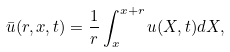<formula> <loc_0><loc_0><loc_500><loc_500>\bar { u } ( r , x , t ) = \frac { 1 } { r } \int _ { x } ^ { x + r } u ( X , t ) d X ,</formula> 